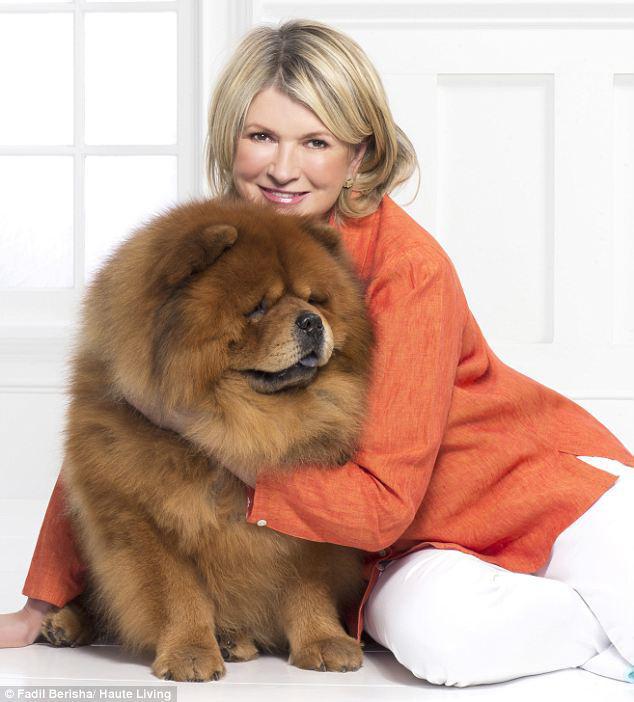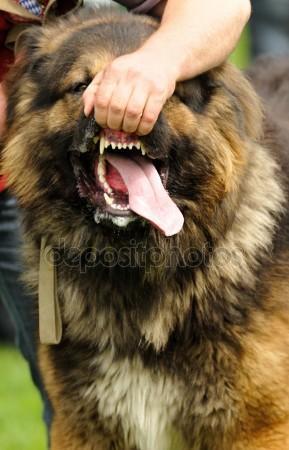The first image is the image on the left, the second image is the image on the right. For the images displayed, is the sentence "The image on the left contains a person holding onto a dog." factually correct? Answer yes or no. Yes. The first image is the image on the left, the second image is the image on the right. Analyze the images presented: Is the assertion "A female is touching a dog with her hands." valid? Answer yes or no. Yes. 